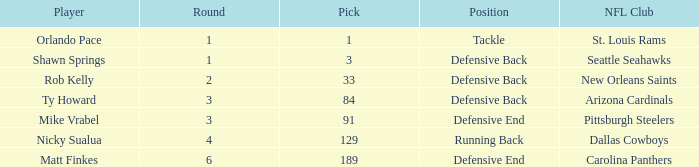Which athlete has a position of defensive back and a round lower than 2? Shawn Springs. 